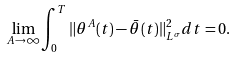Convert formula to latex. <formula><loc_0><loc_0><loc_500><loc_500>\lim _ { A \rightarrow \infty } \int _ { 0 } ^ { T } \| \theta ^ { A } ( t ) - \bar { \theta } ( t ) \| _ { L ^ { \sigma } } ^ { 2 } d t = 0 .</formula> 